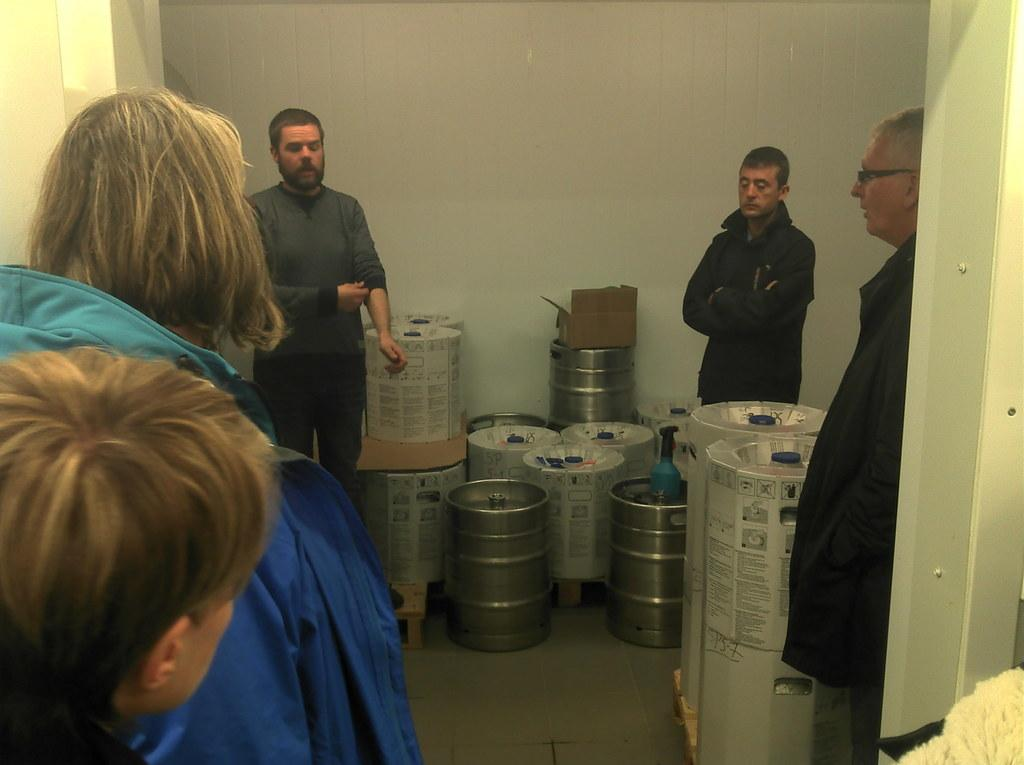How many people are in the image? There is a group of persons standing in the image. What can be seen in the center of the image? There are objects in the center of the image. What type of tools is the carpenter using in the image? There is no carpenter or tools present in the image. What angle is the basketball being shot at in the image? There is no basketball or any indication of a basketball game in the image. 